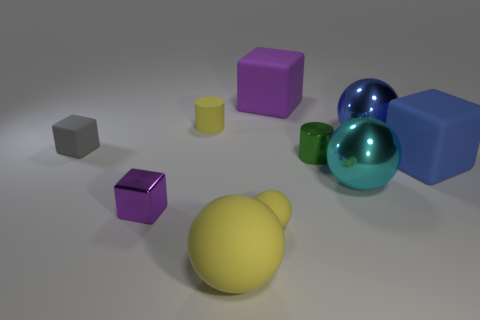Is the number of matte objects that are right of the tiny matte sphere the same as the number of large purple blocks?
Offer a terse response. No. What number of objects are either purple objects behind the small matte cylinder or small gray metal cylinders?
Your response must be concise. 1. There is a tiny cylinder on the left side of the large purple thing; is its color the same as the small ball?
Your answer should be very brief. Yes. There is a yellow matte sphere that is to the left of the small rubber sphere; what size is it?
Give a very brief answer. Large. What is the shape of the yellow matte object that is behind the small rubber object that is in front of the large blue rubber object?
Ensure brevity in your answer.  Cylinder. There is another small thing that is the same shape as the cyan metallic thing; what is its color?
Provide a succinct answer. Yellow. Does the blue object behind the green metal cylinder have the same size as the big yellow rubber ball?
Provide a short and direct response. Yes. There is a tiny rubber object that is the same color as the small sphere; what is its shape?
Offer a very short reply. Cylinder. How many large yellow spheres have the same material as the small purple block?
Give a very brief answer. 0. There is a large sphere that is in front of the tiny matte object that is on the right side of the small yellow object that is behind the tiny purple metal thing; what is it made of?
Your response must be concise. Rubber. 